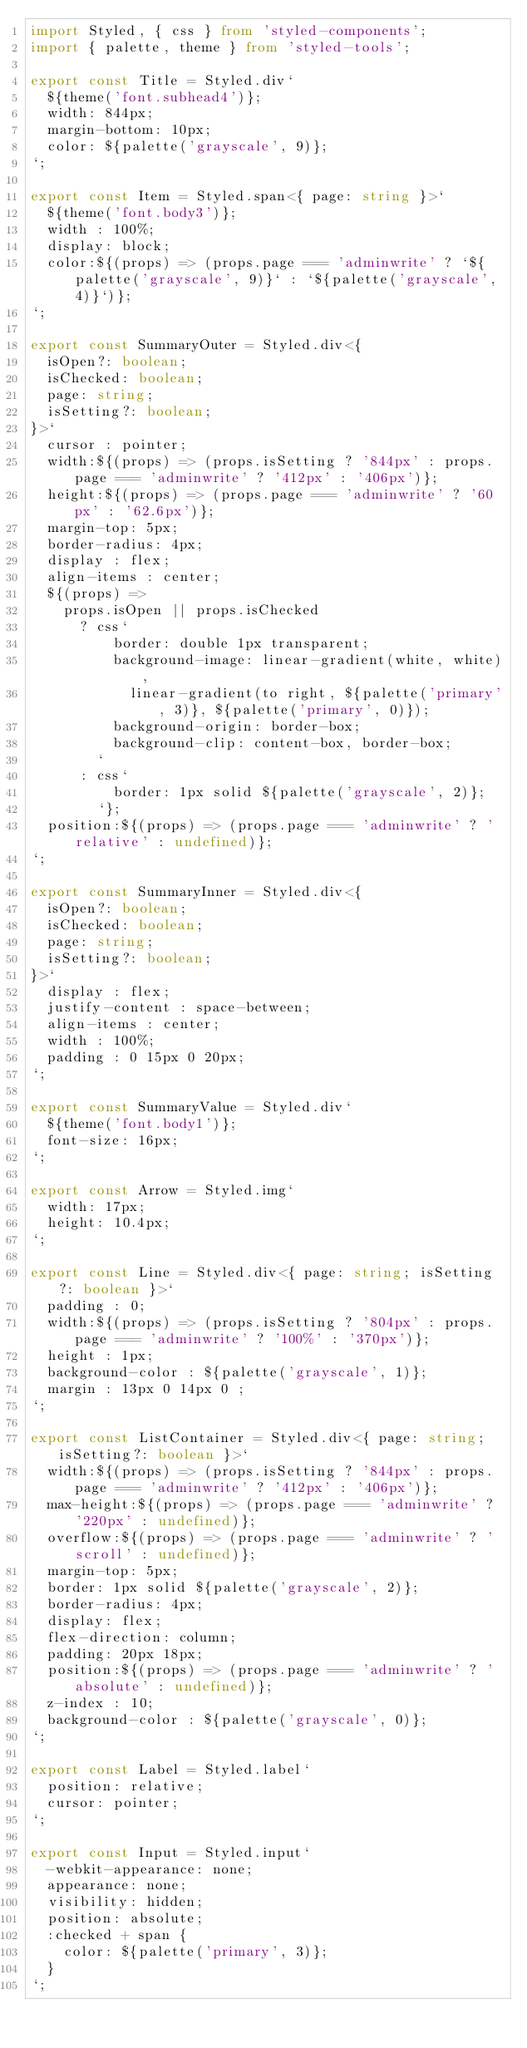Convert code to text. <code><loc_0><loc_0><loc_500><loc_500><_TypeScript_>import Styled, { css } from 'styled-components';
import { palette, theme } from 'styled-tools';

export const Title = Styled.div`
  ${theme('font.subhead4')};
  width: 844px;
  margin-bottom: 10px;
  color: ${palette('grayscale', 9)};
`;

export const Item = Styled.span<{ page: string }>`
  ${theme('font.body3')};
  width : 100%;
  display: block;
  color:${(props) => (props.page === 'adminwrite' ? `${palette('grayscale', 9)}` : `${palette('grayscale', 4)}`)};
`;

export const SummaryOuter = Styled.div<{
  isOpen?: boolean;
  isChecked: boolean;
  page: string;
  isSetting?: boolean;
}>`
  cursor : pointer;
  width:${(props) => (props.isSetting ? '844px' : props.page === 'adminwrite' ? '412px' : '406px')};
  height:${(props) => (props.page === 'adminwrite' ? '60px' : '62.6px')};
  margin-top: 5px;
  border-radius: 4px;
  display : flex;
  align-items : center;
  ${(props) =>
    props.isOpen || props.isChecked
      ? css`
          border: double 1px transparent;
          background-image: linear-gradient(white, white),
            linear-gradient(to right, ${palette('primary', 3)}, ${palette('primary', 0)});
          background-origin: border-box;
          background-clip: content-box, border-box;
        `
      : css`
          border: 1px solid ${palette('grayscale', 2)};
        `};   
  position:${(props) => (props.page === 'adminwrite' ? 'relative' : undefined)};
`;

export const SummaryInner = Styled.div<{
  isOpen?: boolean;
  isChecked: boolean;
  page: string;
  isSetting?: boolean;
}>`
  display : flex;
  justify-content : space-between;
  align-items : center;
  width : 100%;
  padding : 0 15px 0 20px;
`;

export const SummaryValue = Styled.div`
  ${theme('font.body1')};
  font-size: 16px;
`;

export const Arrow = Styled.img`
  width: 17px;
  height: 10.4px;
`;

export const Line = Styled.div<{ page: string; isSetting?: boolean }>`
  padding : 0;
  width:${(props) => (props.isSetting ? '804px' : props.page === 'adminwrite' ? '100%' : '370px')};
  height : 1px;
  background-color : ${palette('grayscale', 1)};
  margin : 13px 0 14px 0 ;
`;

export const ListContainer = Styled.div<{ page: string; isSetting?: boolean }>`
  width:${(props) => (props.isSetting ? '844px' : props.page === 'adminwrite' ? '412px' : '406px')};
  max-height:${(props) => (props.page === 'adminwrite' ? '220px' : undefined)};
  overflow:${(props) => (props.page === 'adminwrite' ? 'scroll' : undefined)};
  margin-top: 5px;
  border: 1px solid ${palette('grayscale', 2)};
  border-radius: 4px;
  display: flex;
  flex-direction: column;
  padding: 20px 18px;
  position:${(props) => (props.page === 'adminwrite' ? 'absolute' : undefined)};
  z-index : 10;
  background-color : ${palette('grayscale', 0)};
`;

export const Label = Styled.label`
  position: relative;
  cursor: pointer;
`;

export const Input = Styled.input`
  -webkit-appearance: none;
  appearance: none;
  visibility: hidden;
  position: absolute;
  :checked + span {
    color: ${palette('primary', 3)};
  }
`;
</code> 